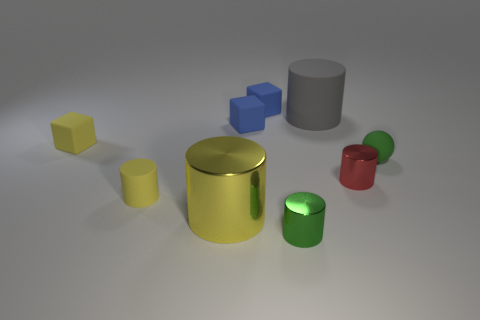How many large things are either green rubber spheres or green metallic objects?
Keep it short and to the point. 0. Does the large cylinder that is in front of the yellow rubber block have the same material as the small green sphere that is to the right of the big gray thing?
Your response must be concise. No. What is the material of the tiny blue thing that is behind the gray cylinder?
Keep it short and to the point. Rubber. How many metallic objects are either gray cylinders or tiny yellow cylinders?
Provide a short and direct response. 0. There is a big cylinder behind the block that is on the left side of the large yellow cylinder; what color is it?
Your response must be concise. Gray. Is the material of the tiny yellow cylinder the same as the big cylinder that is on the left side of the small green cylinder?
Offer a terse response. No. The cylinder that is left of the yellow cylinder to the right of the rubber cylinder in front of the ball is what color?
Make the answer very short. Yellow. Are there any other things that have the same shape as the red shiny object?
Make the answer very short. Yes. Is the number of big gray rubber cylinders greater than the number of small brown blocks?
Offer a very short reply. Yes. How many small matte things are in front of the yellow cube and right of the large yellow shiny object?
Your answer should be compact. 1. 